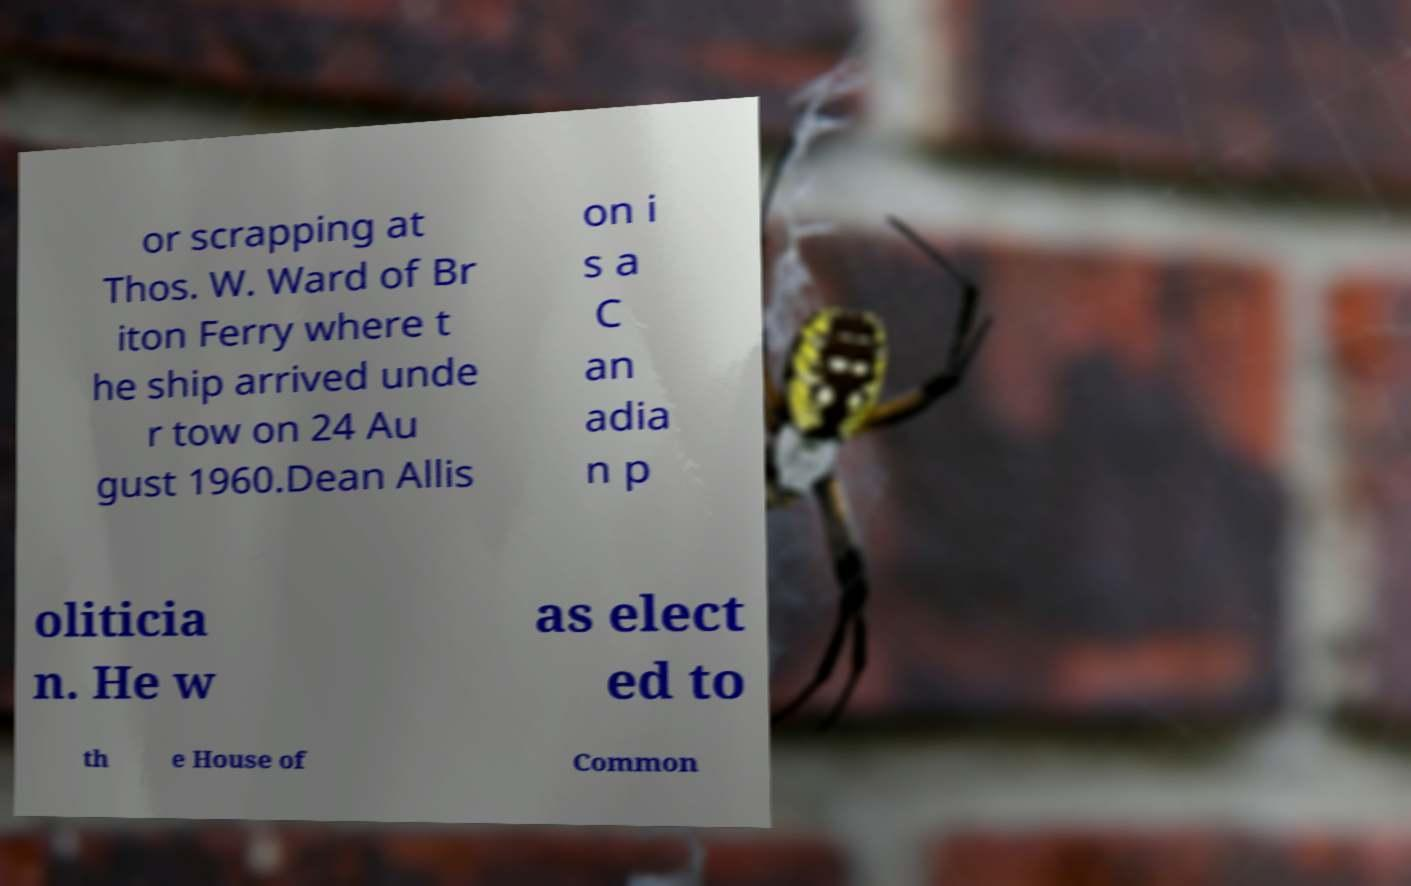Can you read and provide the text displayed in the image?This photo seems to have some interesting text. Can you extract and type it out for me? or scrapping at Thos. W. Ward of Br iton Ferry where t he ship arrived unde r tow on 24 Au gust 1960.Dean Allis on i s a C an adia n p oliticia n. He w as elect ed to th e House of Common 